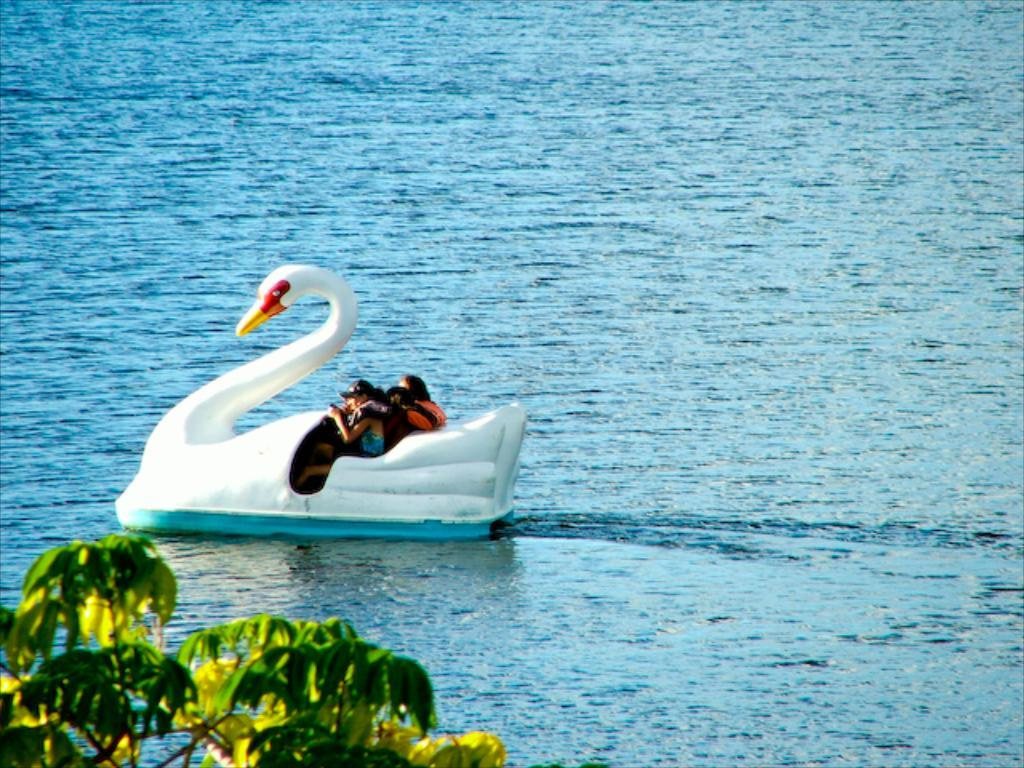What type of boat is depicted in the image? There is a boat in the shape of a duck in the image. Where is the boat located? The boat is on the water. Are there any passengers on the boat? Yes, there are people sitting on the boat. What can be seen at the bottom side of the image? There is a tree at the bottom side of the image. What grade of meat is being used to cook on the boat in the image? There is no meat or cooking activity present in the image; it features a duck-shaped boat with people sitting on it. Is there a swing visible in the image? No, there is no swing present in the image. 